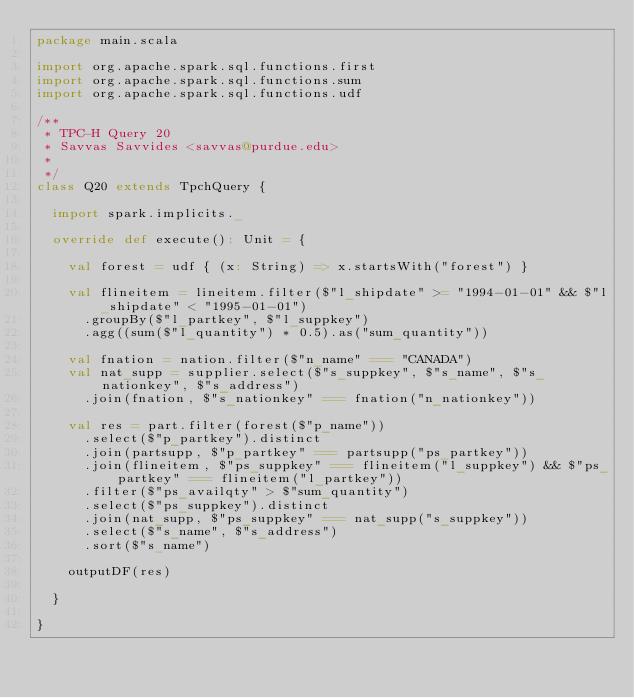Convert code to text. <code><loc_0><loc_0><loc_500><loc_500><_Scala_>package main.scala

import org.apache.spark.sql.functions.first
import org.apache.spark.sql.functions.sum
import org.apache.spark.sql.functions.udf

/**
 * TPC-H Query 20
 * Savvas Savvides <savvas@purdue.edu>
 *
 */
class Q20 extends TpchQuery {

  import spark.implicits._

  override def execute(): Unit = {

    val forest = udf { (x: String) => x.startsWith("forest") }

    val flineitem = lineitem.filter($"l_shipdate" >= "1994-01-01" && $"l_shipdate" < "1995-01-01")
      .groupBy($"l_partkey", $"l_suppkey")
      .agg((sum($"l_quantity") * 0.5).as("sum_quantity"))

    val fnation = nation.filter($"n_name" === "CANADA")
    val nat_supp = supplier.select($"s_suppkey", $"s_name", $"s_nationkey", $"s_address")
      .join(fnation, $"s_nationkey" === fnation("n_nationkey"))

    val res = part.filter(forest($"p_name"))
      .select($"p_partkey").distinct
      .join(partsupp, $"p_partkey" === partsupp("ps_partkey"))
      .join(flineitem, $"ps_suppkey" === flineitem("l_suppkey") && $"ps_partkey" === flineitem("l_partkey"))
      .filter($"ps_availqty" > $"sum_quantity")
      .select($"ps_suppkey").distinct
      .join(nat_supp, $"ps_suppkey" === nat_supp("s_suppkey"))
      .select($"s_name", $"s_address")
      .sort($"s_name")

    outputDF(res)

  }

}
</code> 